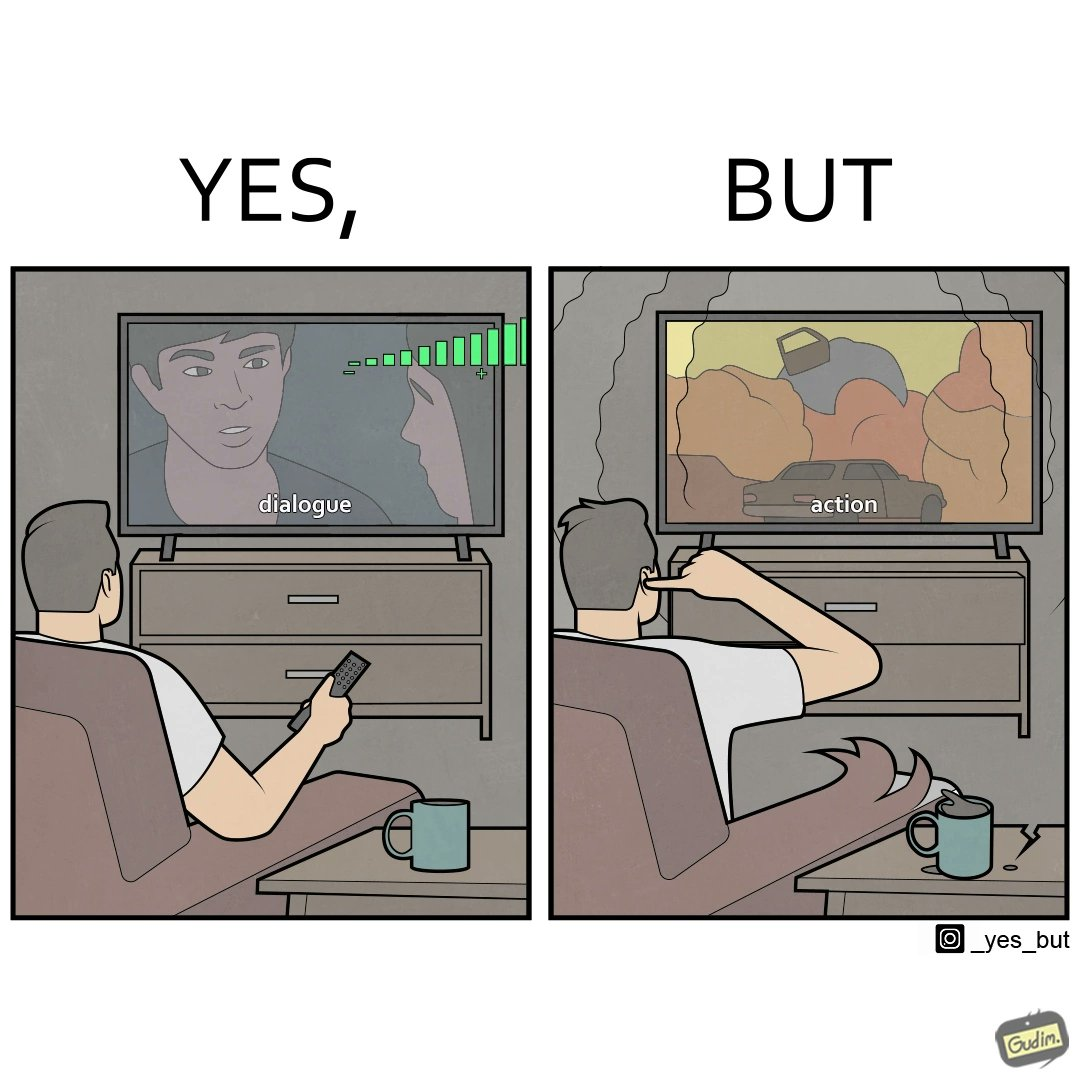Describe what you see in this image. The action scenes of the movies or TV programs are mostly low in sound and people aren't able to hear them properly but in the action scenes due to the background music and other noise the sound becomes unbearable to some peoples 